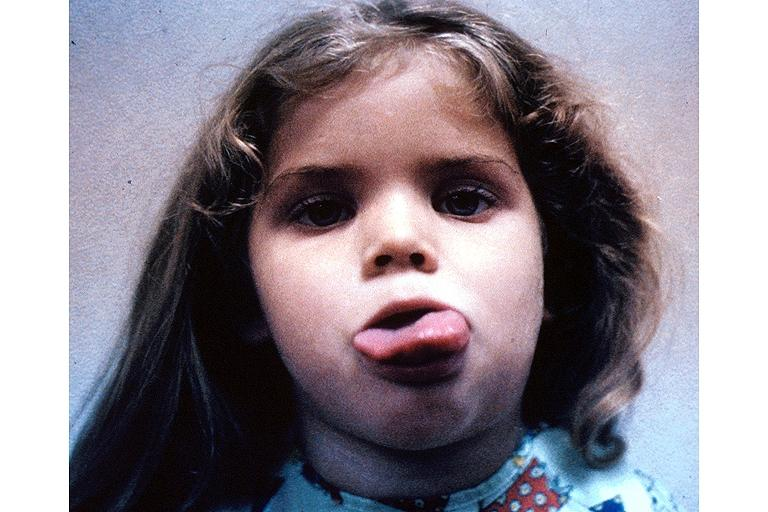does omphalocele show neurofibromatosis-macroglossi?
Answer the question using a single word or phrase. No 